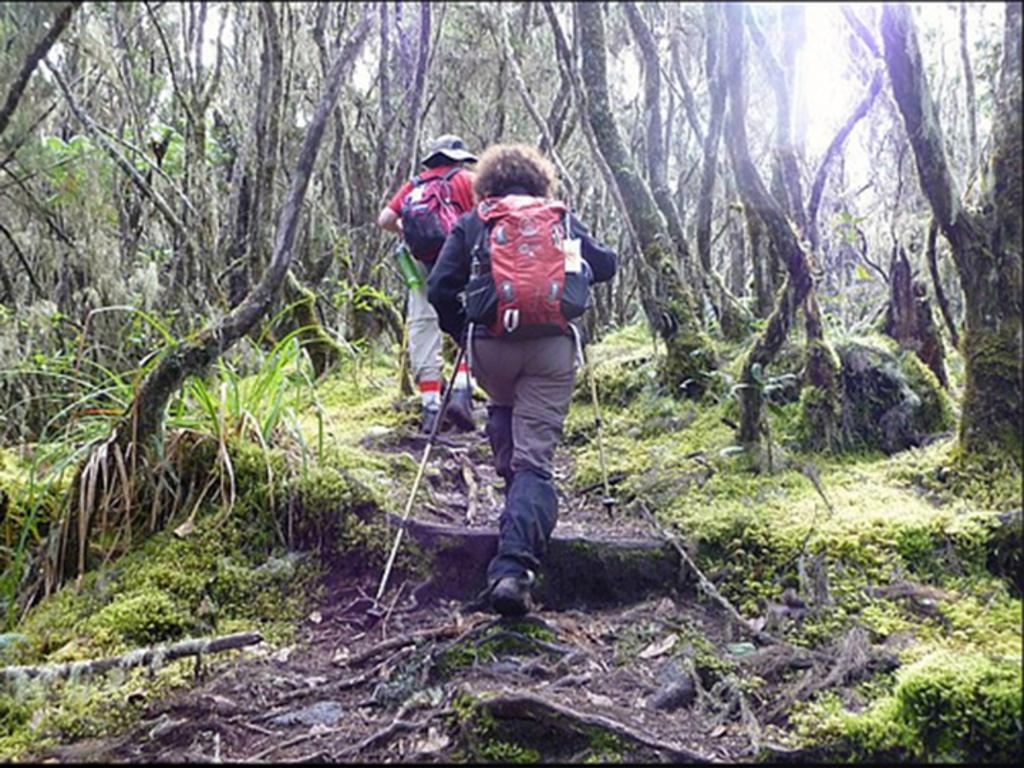How would you summarize this image in a sentence or two? In this image we can see two persons wearing backpacks are walking on the ground and a person is holding a stick and there are few trees. 